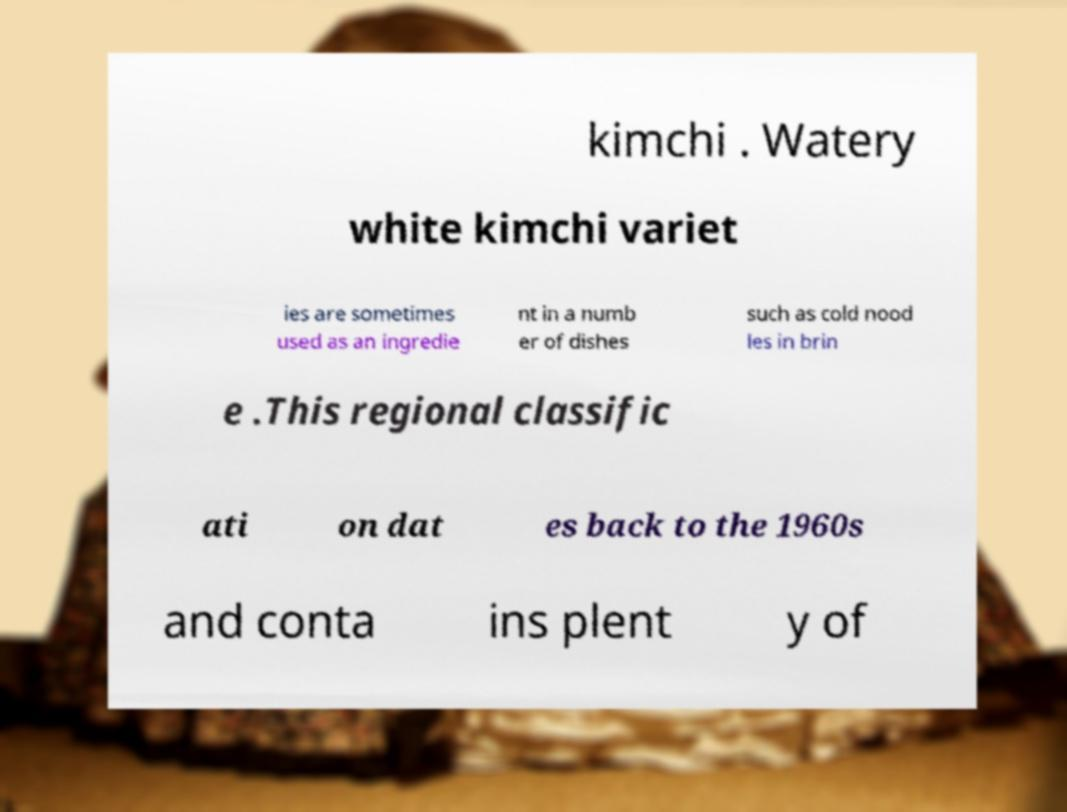Please read and relay the text visible in this image. What does it say? kimchi . Watery white kimchi variet ies are sometimes used as an ingredie nt in a numb er of dishes such as cold nood les in brin e .This regional classific ati on dat es back to the 1960s and conta ins plent y of 